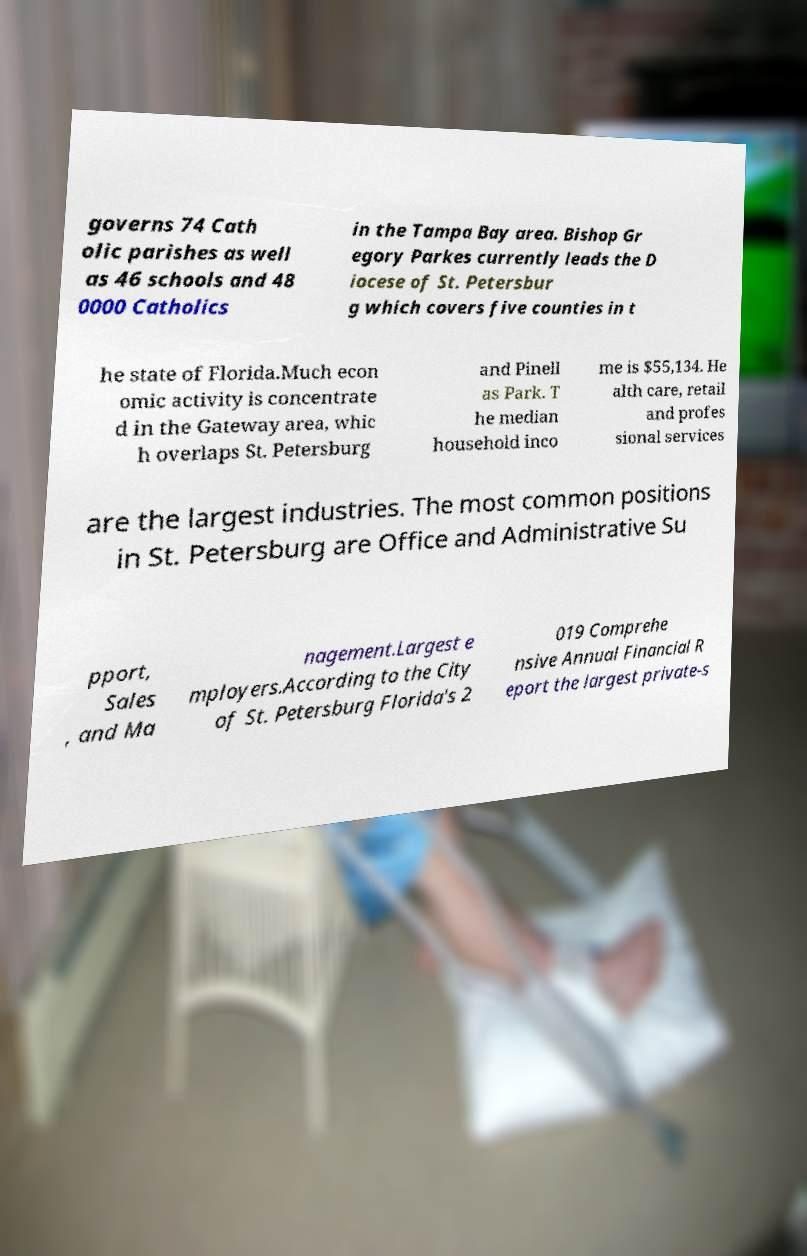Can you read and provide the text displayed in the image?This photo seems to have some interesting text. Can you extract and type it out for me? governs 74 Cath olic parishes as well as 46 schools and 48 0000 Catholics in the Tampa Bay area. Bishop Gr egory Parkes currently leads the D iocese of St. Petersbur g which covers five counties in t he state of Florida.Much econ omic activity is concentrate d in the Gateway area, whic h overlaps St. Petersburg and Pinell as Park. T he median household inco me is $55,134. He alth care, retail and profes sional services are the largest industries. The most common positions in St. Petersburg are Office and Administrative Su pport, Sales , and Ma nagement.Largest e mployers.According to the City of St. Petersburg Florida's 2 019 Comprehe nsive Annual Financial R eport the largest private-s 